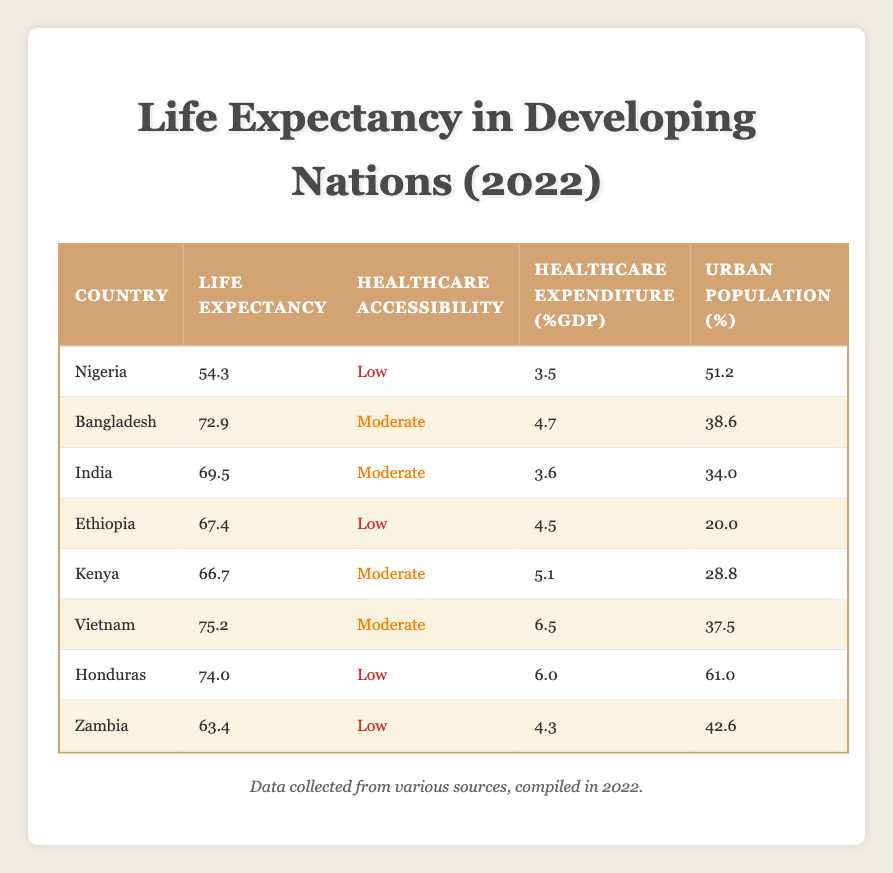What is the life expectancy of Nigeria? The table lists the life expectancy for Nigeria as 54.3. This value can be found directly under the Life Expectancy column corresponding to Nigeria.
Answer: 54.3 Which country has the highest life expectancy? Examining the Life Expectancy column, the highest value is 75.2, which corresponds to Vietnam. This is the only country with this value, confirming it has the highest life expectancy.
Answer: Vietnam How many countries have moderate healthcare accessibility? By counting the occurrences of "Moderate" in the Healthcare Accessibility column, there are four countries: Bangladesh, India, Kenya, and Vietnam.
Answer: 4 What is the average life expectancy of countries with low healthcare accessibility? The countries with low healthcare accessibility are Nigeria, Ethiopia, Honduras, and Zambia. Their life expectancies are 54.3, 67.4, 74.0, and 63.4, respectively. The sum of these values is 54.3 + 67.4 + 74.0 + 63.4 = 259. To find the average, we divide by the number of countries, which is 4. So, 259 / 4 = 64.75.
Answer: 64.75 Is healthcare expenditure higher for countries with moderate healthcare accessibility than for those with low accessibility? We compare the healthcare expenditure percentages: Moderate accessibility countries (Bangladesh: 4.7, India: 3.6, Kenya: 5.1, Vietnam: 6.5) average out to (4.7 + 3.6 + 5.1 + 6.5) / 4 = 5.0. Low accessibility countries (Nigeria: 3.5, Ethiopia: 4.5, Honduras: 6.0, Zambia: 4.3) average out to (3.5 + 4.5 + 6.0 + 4.3) / 4 = 4.33. Since 5.0 > 4.33, the answer is yes.
Answer: Yes Which country has the lowest urban population percentage? By reviewing the Urban Population column, Ethiopia has the lowest percentage at 20.0. This can be seen clearly in the corresponding row for Ethiopia.
Answer: Ethiopia What is the difference in life expectancy between Vietnam and Nigeria? The life expectancy of Vietnam is 75.2 and Nigeria is 54.3. To find the difference, we calculate 75.2 - 54.3 = 20.9. Therefore, the difference is 20.9 years.
Answer: 20.9 Does India have a higher life expectancy than Kenya? Checking the Life Expectancy column, India has a life expectancy of 69.5 while Kenya's is 66.7. Since 69.5 is greater than 66.7, the statement is true.
Answer: Yes How many countries have life expectancy below 65? By reviewing the Life Expectancy column, we see that Nigeria (54.3), Ethiopia (67.4), and Zambia (63.4) have values below 65, counting to three countries in total.
Answer: 3 